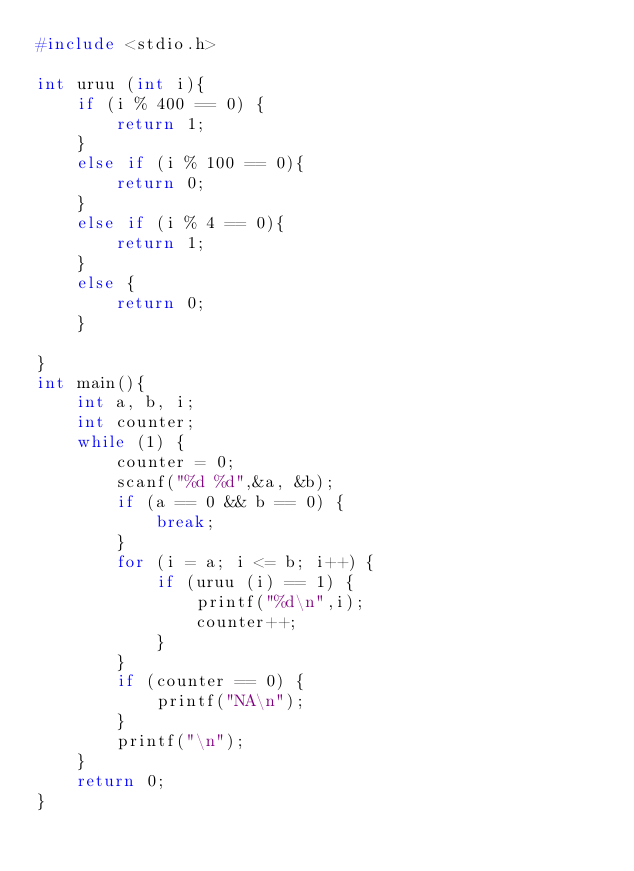<code> <loc_0><loc_0><loc_500><loc_500><_C_>#include <stdio.h>

int uruu (int i){
    if (i % 400 == 0) {
        return 1;
    }
    else if (i % 100 == 0){
        return 0;
    }
    else if (i % 4 == 0){
        return 1;
    }
    else {
        return 0;
    }
    
}
int main(){
    int a, b, i;
    int counter;
    while (1) {
        counter = 0;
        scanf("%d %d",&a, &b);
        if (a == 0 && b == 0) {
            break;
        }
        for (i = a; i <= b; i++) {
            if (uruu (i) == 1) {
                printf("%d\n",i);
                counter++;
            }
        }
        if (counter == 0) {
            printf("NA\n");
        }
        printf("\n");
    }
    return 0;
}</code> 